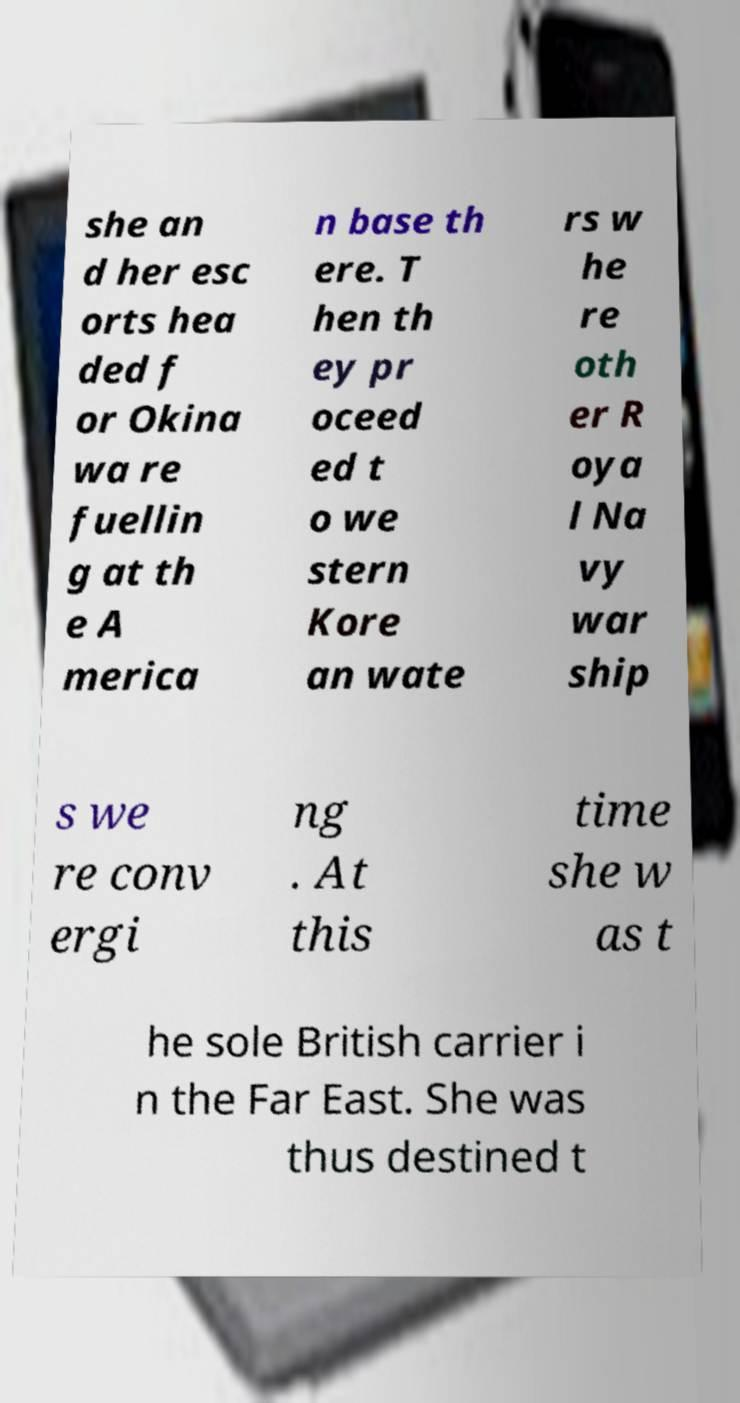Can you read and provide the text displayed in the image?This photo seems to have some interesting text. Can you extract and type it out for me? she an d her esc orts hea ded f or Okina wa re fuellin g at th e A merica n base th ere. T hen th ey pr oceed ed t o we stern Kore an wate rs w he re oth er R oya l Na vy war ship s we re conv ergi ng . At this time she w as t he sole British carrier i n the Far East. She was thus destined t 